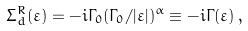<formula> <loc_0><loc_0><loc_500><loc_500>\Sigma ^ { R } _ { d } ( \varepsilon ) = - i \Gamma _ { 0 } ( \Gamma _ { 0 } / | \varepsilon | ) ^ { \alpha } \equiv - i \Gamma ( \varepsilon ) \, ,</formula> 